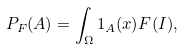Convert formula to latex. <formula><loc_0><loc_0><loc_500><loc_500>P _ { F } ( A ) = \int _ { \Omega } 1 _ { A } ( x ) F ( I ) ,</formula> 